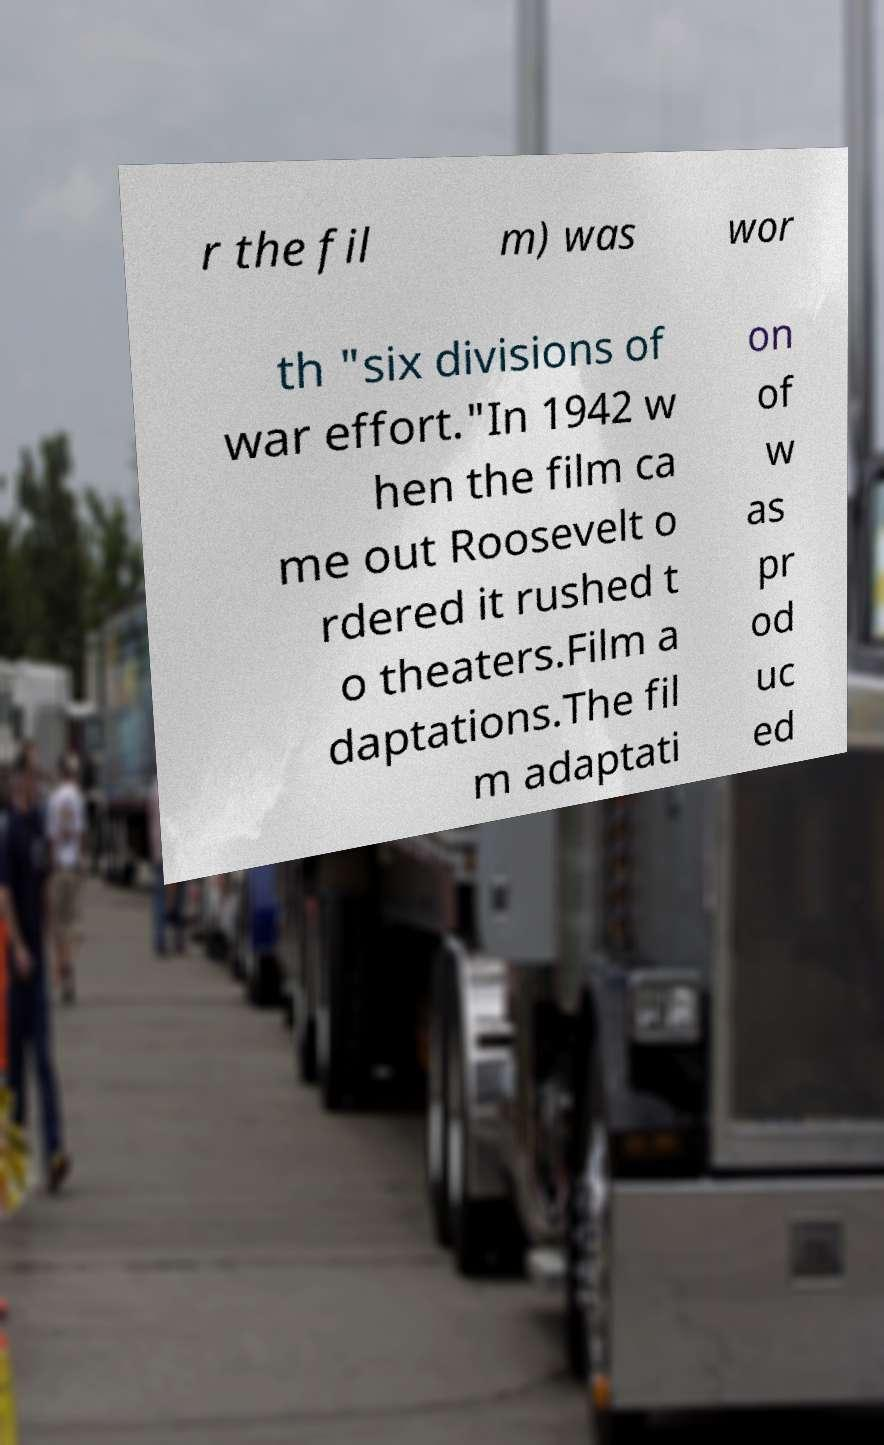Could you assist in decoding the text presented in this image and type it out clearly? r the fil m) was wor th "six divisions of war effort."In 1942 w hen the film ca me out Roosevelt o rdered it rushed t o theaters.Film a daptations.The fil m adaptati on of w as pr od uc ed 